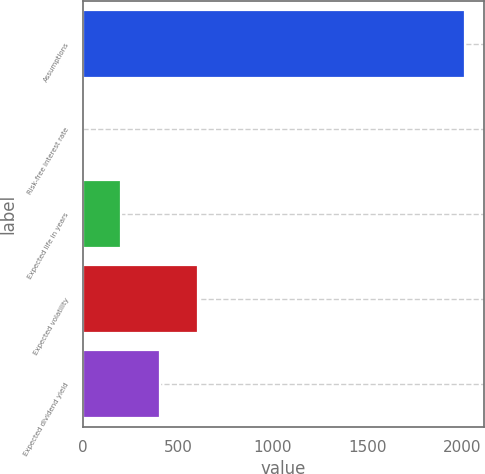Convert chart to OTSL. <chart><loc_0><loc_0><loc_500><loc_500><bar_chart><fcel>Assumptions<fcel>Risk-free interest rate<fcel>Expected life in years<fcel>Expected volatility<fcel>Expected dividend yield<nl><fcel>2012<fcel>0.57<fcel>201.71<fcel>603.99<fcel>402.85<nl></chart> 